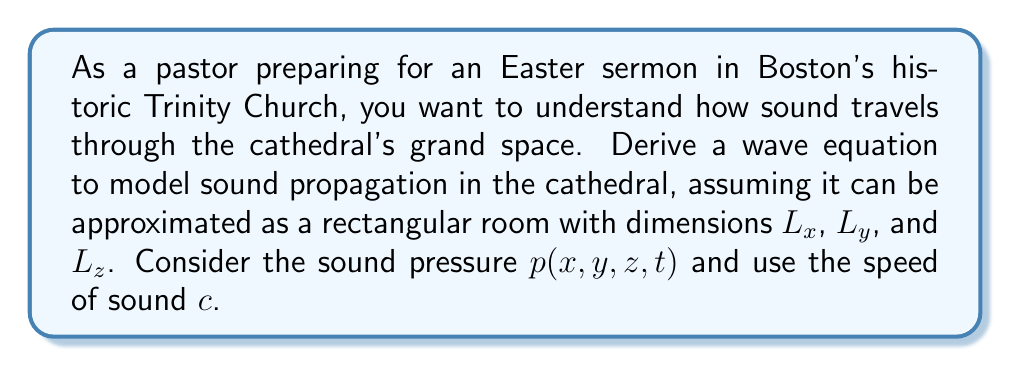Help me with this question. To derive the wave equation for sound propagation in the cathedral, we'll follow these steps:

1) First, we need to consider the basic principles of sound propagation. Sound travels as a pressure wave through air, and its behavior can be described using the principles of fluid dynamics and thermodynamics.

2) We'll start with the linearized continuity equation:

   $$\frac{\partial \rho}{\partial t} + \rho_0 \nabla \cdot \mathbf{v} = 0$$

   where $\rho$ is the density perturbation, $\rho_0$ is the equilibrium density, and $\mathbf{v}$ is the particle velocity.

3) Next, we'll use the linearized Euler equation:

   $$\rho_0 \frac{\partial \mathbf{v}}{\partial t} + \nabla p = 0$$

   where $p$ is the pressure perturbation.

4) We also need the equation of state for an adiabatic process:

   $$p = c^2 \rho$$

   where $c$ is the speed of sound.

5) Now, we'll take the time derivative of the continuity equation:

   $$\frac{\partial^2 \rho}{\partial t^2} + \rho_0 \frac{\partial}{\partial t}(\nabla \cdot \mathbf{v}) = 0$$

6) Next, we'll take the divergence of the Euler equation:

   $$\rho_0 \frac{\partial}{\partial t}(\nabla \cdot \mathbf{v}) + \nabla^2 p = 0$$

7) Substituting the result from step 6 into the equation from step 5:

   $$\frac{\partial^2 \rho}{\partial t^2} - \nabla^2 p = 0$$

8) Using the equation of state from step 4, we can replace $\rho$ with $p/c^2$:

   $$\frac{1}{c^2}\frac{\partial^2 p}{\partial t^2} - \nabla^2 p = 0$$

9) Rearranging, we get the wave equation for sound pressure:

   $$\frac{\partial^2 p}{\partial t^2} = c^2 \nabla^2 p$$

10) In the rectangular cathedral with dimensions $L_x$, $L_y$, and $L_z$, the Laplacian operator $\nabla^2$ in Cartesian coordinates is:

    $$\nabla^2 = \frac{\partial^2}{\partial x^2} + \frac{\partial^2}{\partial y^2} + \frac{\partial^2}{\partial z^2}$$

11) Therefore, the final wave equation for sound propagation in the cathedral is:

    $$\frac{\partial^2 p}{\partial t^2} = c^2 \left(\frac{\partial^2 p}{\partial x^2} + \frac{\partial^2 p}{\partial y^2} + \frac{\partial^2 p}{\partial z^2}\right)$$

This equation describes how the sound pressure $p(x,y,z,t)$ varies in space and time within the cathedral.
Answer: The wave equation for sound propagation in the cathedral is:

$$\frac{\partial^2 p}{\partial t^2} = c^2 \left(\frac{\partial^2 p}{\partial x^2} + \frac{\partial^2 p}{\partial y^2} + \frac{\partial^2 p}{\partial z^2}\right)$$

where $p(x,y,z,t)$ is the sound pressure, $c$ is the speed of sound, and $x$, $y$, and $z$ are spatial coordinates within the cathedral's dimensions $L_x$, $L_y$, and $L_z$. 